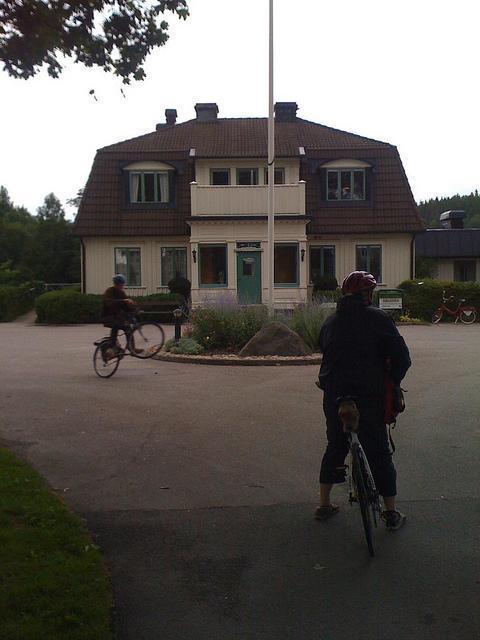How many bicycles are there?
Give a very brief answer. 2. How many stacks of bowls are there?
Give a very brief answer. 0. 